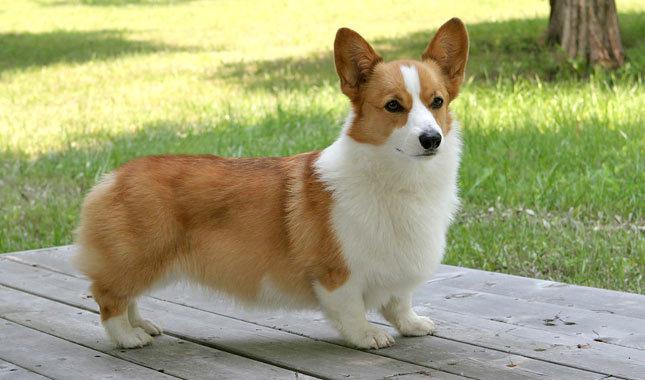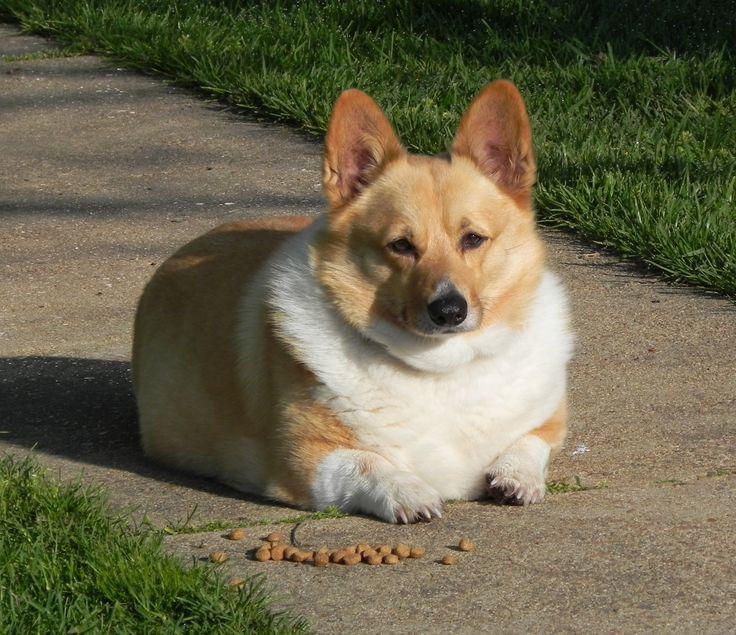The first image is the image on the left, the second image is the image on the right. Given the left and right images, does the statement "In at least one of the images, the corgi is NOT on the grass." hold true? Answer yes or no. Yes. 